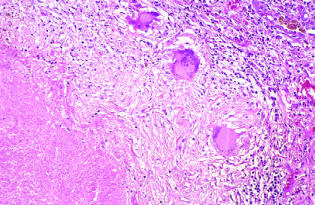does this high-magnification view highlight the histologic features?
Answer the question using a single word or phrase. Yes 